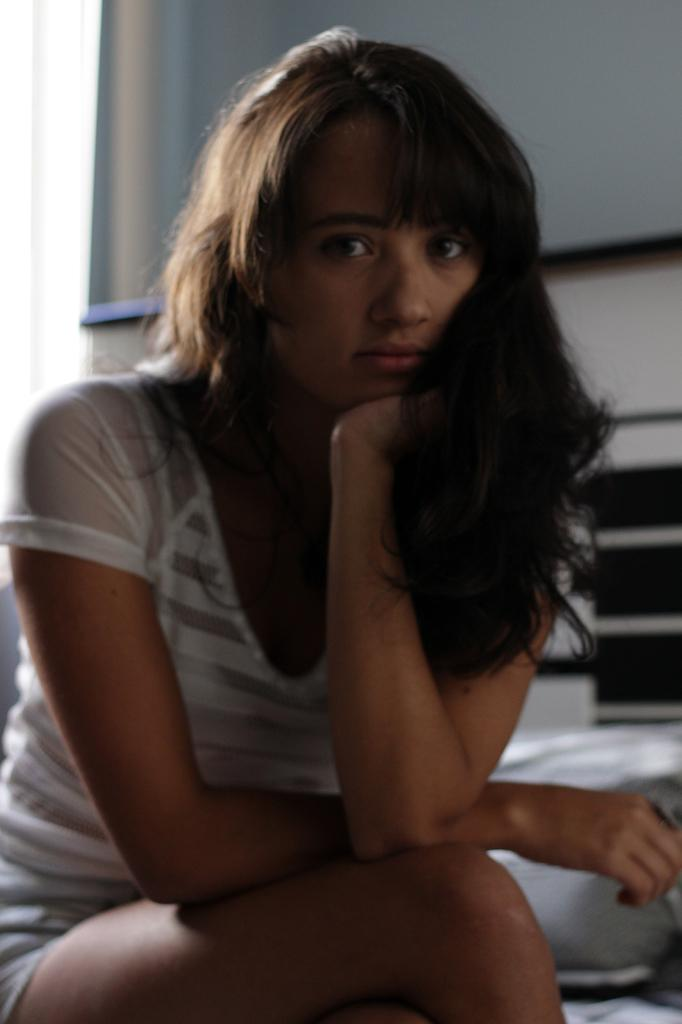Who is the main subject in the image? There is a lady in the image. What is the lady doing in the image? The lady is sitting. Can you describe the background of the image? The background of the image is blurry. What can be seen in the background of the image? There is a wall in the background of the image. What type of hat is the lady wearing in the image? There is no hat visible in the image; the lady is not wearing one. Is the lady using a quill to write in the image? There is no quill or any writing activity depicted in the image. 